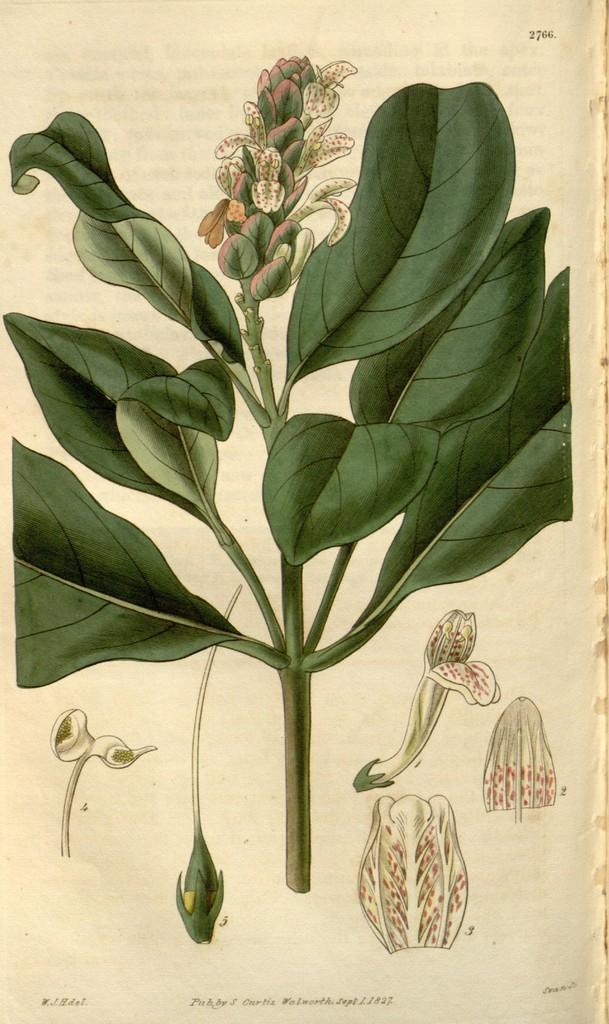What is the main subject of the image? The main subject of the image is an art piece. What elements are included in the art piece? The art piece contains images and text. What type of war is depicted in the art piece? There is no war depicted in the art piece; it contains images and text. How does the expert use the stick in the art piece? There is no stick or expert present in the art piece; it only contains images and text. 